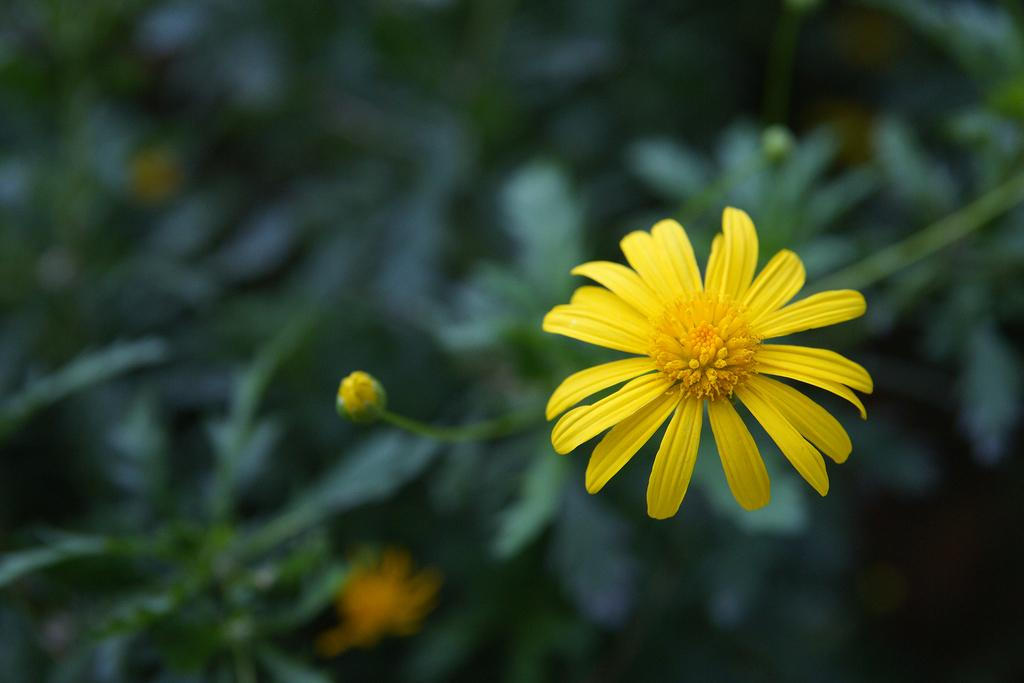What type of flower is in the image? There is a yellow flower in the image. What color is the background of the image? The background of the image is green. What nation is represented by the flower in the image? The image does not represent any nation; it simply shows a yellow flower against a green background. Is there a stage present in the image? There is no stage present in the image; it only features a yellow flower and a green background. 